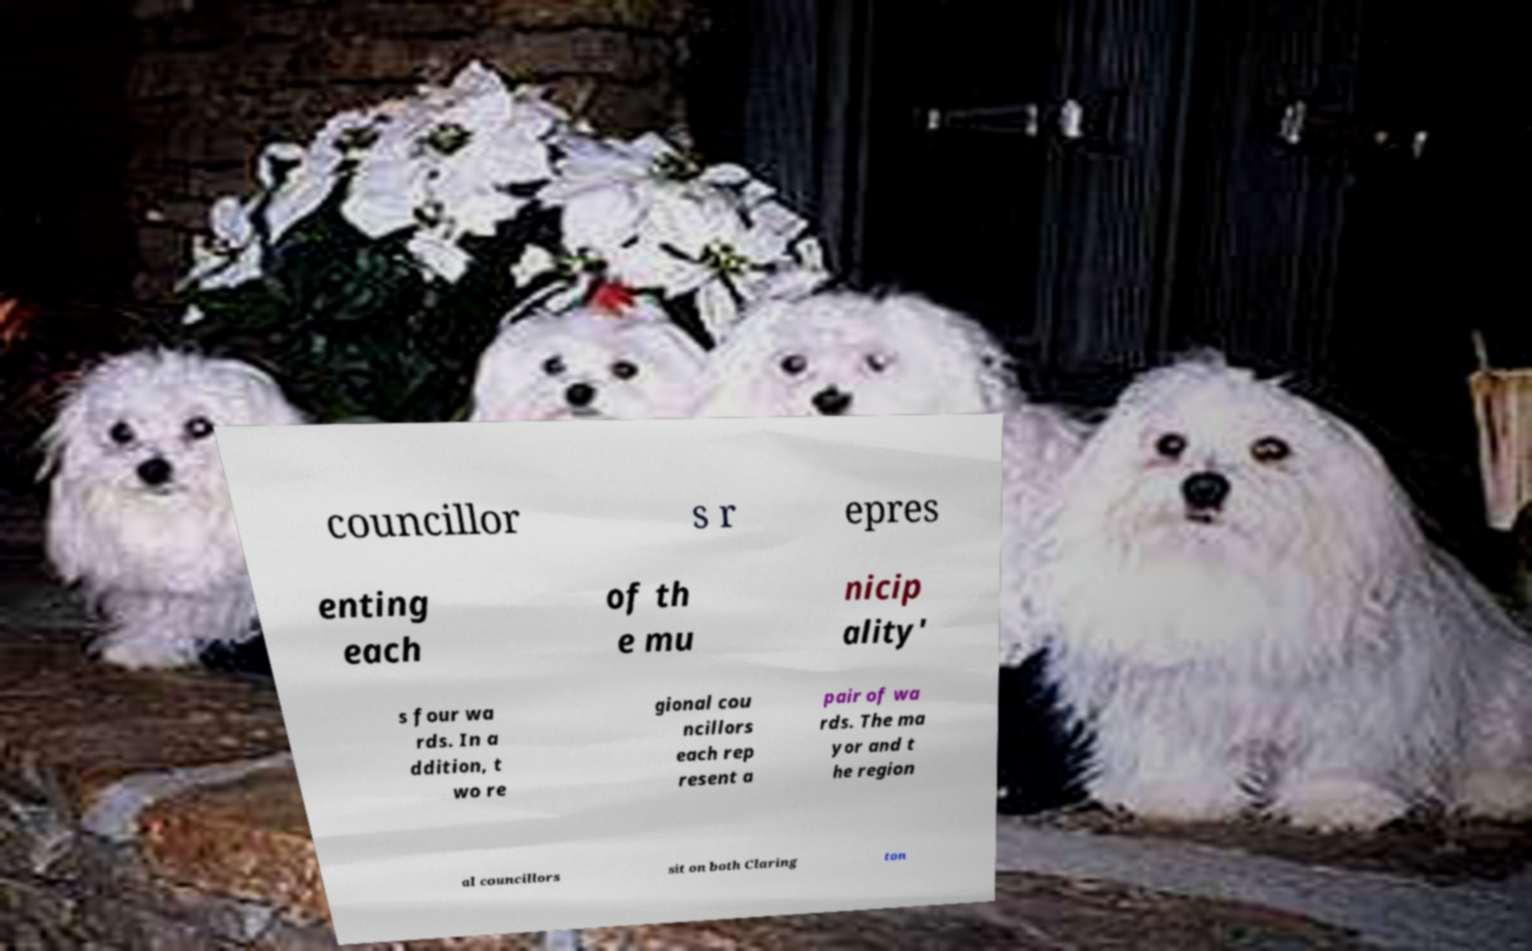Please read and relay the text visible in this image. What does it say? councillor s r epres enting each of th e mu nicip ality' s four wa rds. In a ddition, t wo re gional cou ncillors each rep resent a pair of wa rds. The ma yor and t he region al councillors sit on both Claring ton 